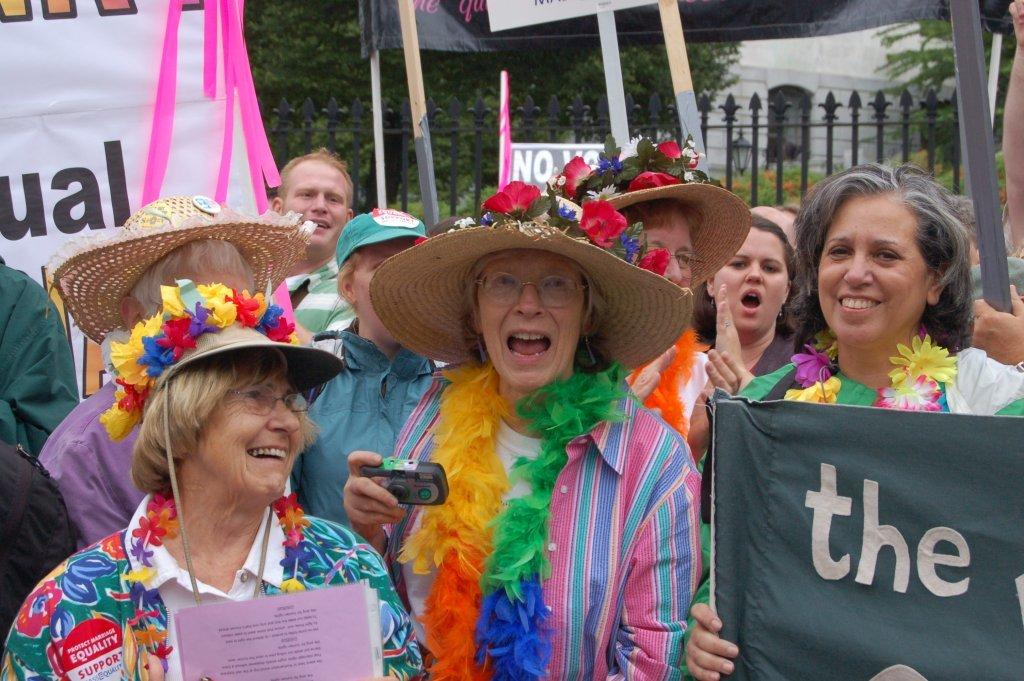What can be seen in the image involving human presence? There are people standing in the image. What type of objects are displayed on the walls or surfaces in the image? There are posters in the image. What kind of barrier or structure is present in the image? There is a fence in the image. What type of vegetation is visible in the image? There are green trees in the image. Can you tell me how many umbrellas are being held by the people in the image? There is no mention of umbrellas in the image, so it cannot be determined if any are being held. What type of seed is being planted by the creator in the image? There is no mention of a creator or seed in the image. 